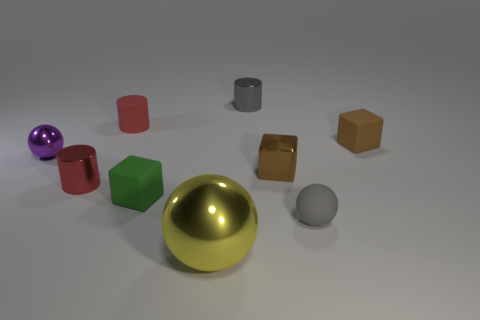How many objects are both to the right of the gray ball and behind the rubber cylinder?
Your answer should be very brief. 0. Is the number of big yellow objects that are behind the gray cylinder greater than the number of large shiny objects that are behind the tiny metallic sphere?
Your answer should be very brief. No. The purple metal sphere is what size?
Your response must be concise. Small. Are there any other small objects of the same shape as the small red shiny object?
Provide a short and direct response. Yes. Does the tiny red rubber object have the same shape as the gray object behind the purple metal sphere?
Your answer should be compact. Yes. How big is the rubber thing that is both to the right of the small brown metallic cube and in front of the purple thing?
Provide a succinct answer. Small. How many metallic balls are there?
Ensure brevity in your answer.  2. There is a gray sphere that is the same size as the purple object; what is it made of?
Provide a short and direct response. Rubber. Is there a metallic object of the same size as the green matte object?
Ensure brevity in your answer.  Yes. Do the small matte cube that is in front of the purple thing and the ball left of the red rubber object have the same color?
Your answer should be very brief. No. 